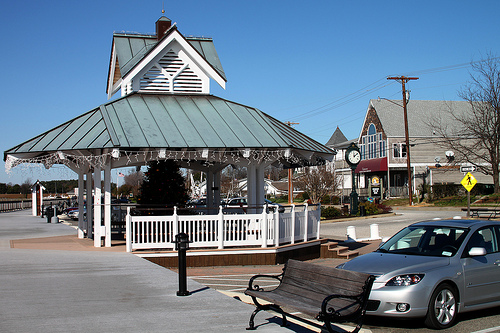Please provide a short description for this region: [0.84, 0.74, 0.92, 0.83]. The region defined by coordinates [0.84, 0.74, 0.92, 0.83] shows a black tire of a car. 